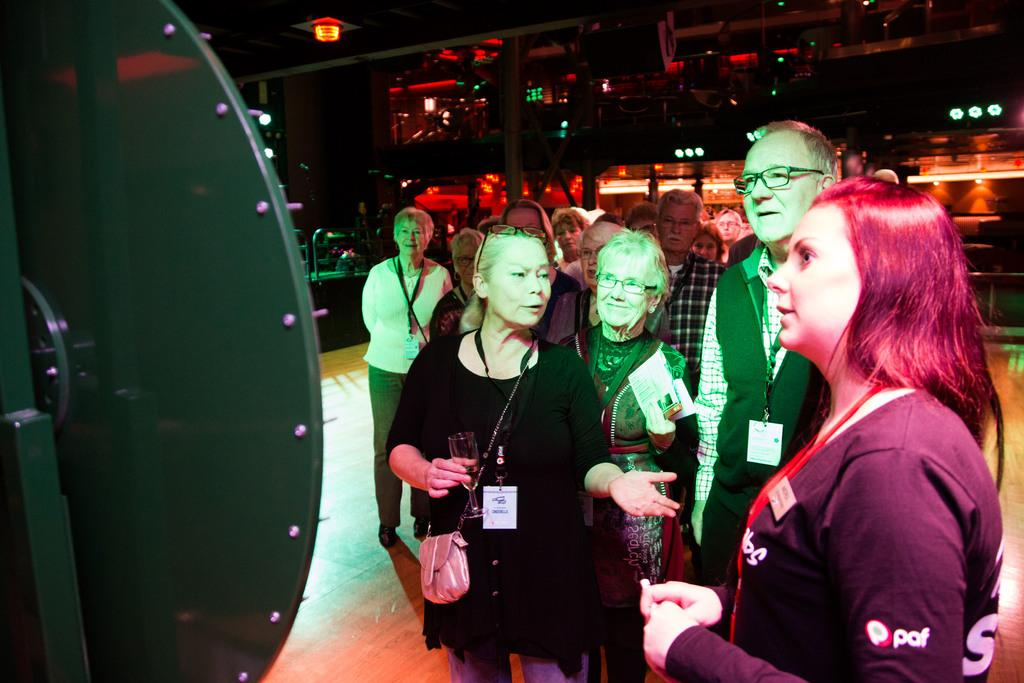What are the people in the image doing? The people in the image are standing in the center. What can be seen on the left side of the image? There is a hoarding on the left side of the image. What is visible in the background of the image? Lights, glass windows, chairs, and other objects can be seen in the background of the image. What action is the judge performing in the image? There is no judge present in the image, so no action can be attributed to a judge. 